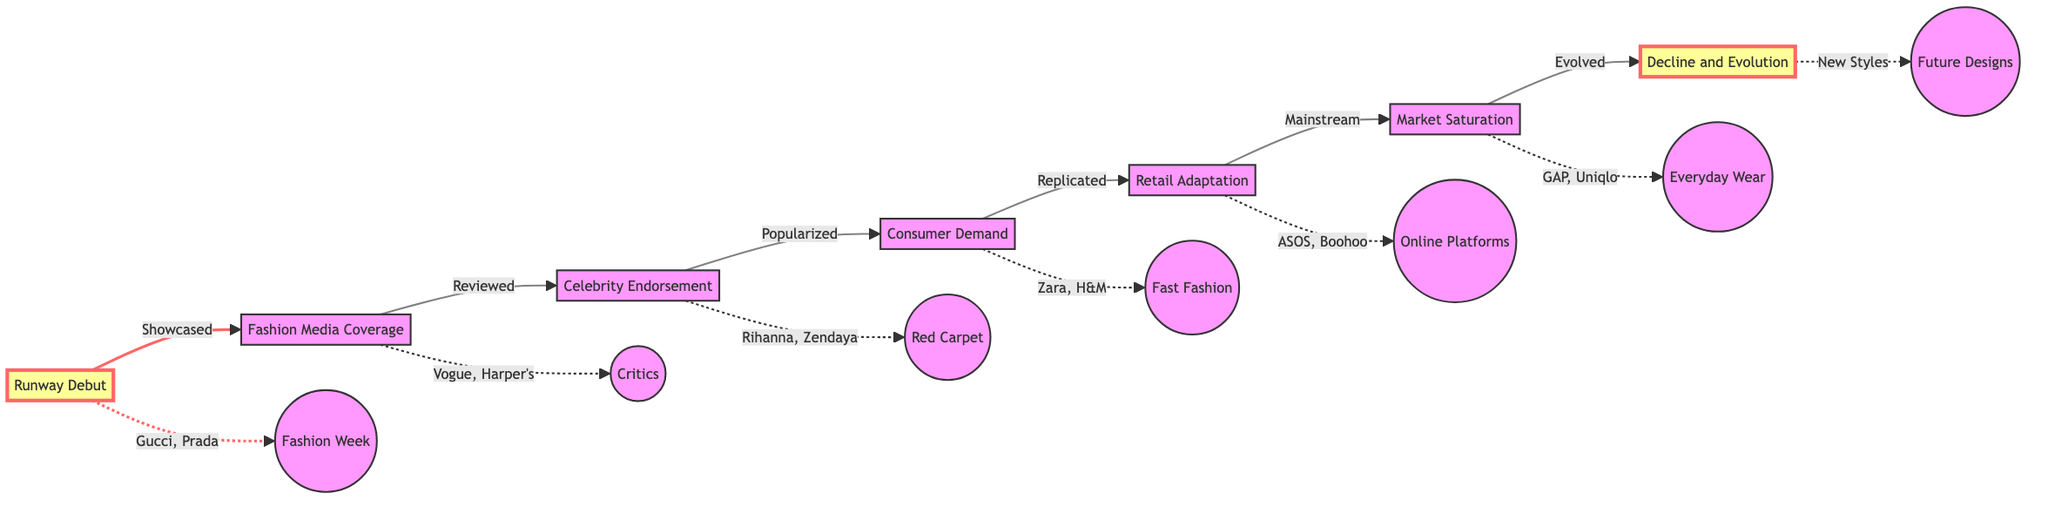What stage comes after Runway Debut? The flowchart shows an arrow leading from "Runway Debut" to "Fashion Media Coverage." This indicates that "Fashion Media Coverage" directly follows "Runway Debut."
Answer: Fashion Media Coverage How many main stages are there in the diagram? By counting the stages listed in the flowchart, we find there are a total of seven distinct stages identified from "Runway Debut" to "Decline and Evolution."
Answer: 7 Which entities are associated with the Celebrity Endorsement stage? The diagram displays a dashed line leading from "Celebrity Endorsement" to the celebrities involved, namely "Rihanna" and "Zendaya." This indicates that these celebrities are associated specifically with this stage.
Answer: Rihanna, Zendaya What stage directly influences Consumer Demand? The arrow in the flowchart indicates that "Celebrity Endorsement" has a direct influence on "Consumer Demand" through increased visibility. Therefore, "Celebrity Endorsement" is the stage that influences "Consumer Demand."
Answer: Celebrity Endorsement What signifies the transition to Market Saturation? The diagram indicates that the transition to "Market Saturation" occurs after "Retail Adaptation," demonstrating that the designs have become broadly available and popular at the retail level.
Answer: Retail Adaptation What stage is labeled with "New Styles"? In the flowchart, the final stage "Decline and Evolution" is associated with "New Styles," suggesting that this stage gives rise to future fashion design trends.
Answer: New Styles Which fast fashion brands are mentioned in relation to Consumer Demand? The flowchart provides a dashed line pointing to "Zara" and "H&M," indicating these fast fashion brands are directly tied to the stage of Consumer Demand due to their quick replication of trends.
Answer: Zara, H&M What is the role of Fashion Media Coverage in the trend journey? The arrow from "Fashion Media Coverage" to "Celebrity Endorsement" denotes that the media coverage serves the role of reviewing and promoting the fashion trends that celebrities subsequently endorse.
Answer: Reviewing and promoting How does the Decline and Evolution stage impact fashion trends? The "Decline and Evolution" stage indicates that as trends become mainstream, it leads to a pivot in focus by critics and designers, creating space for new styles. This transformation affects future fashion trends.
Answer: Creates space for new styles 